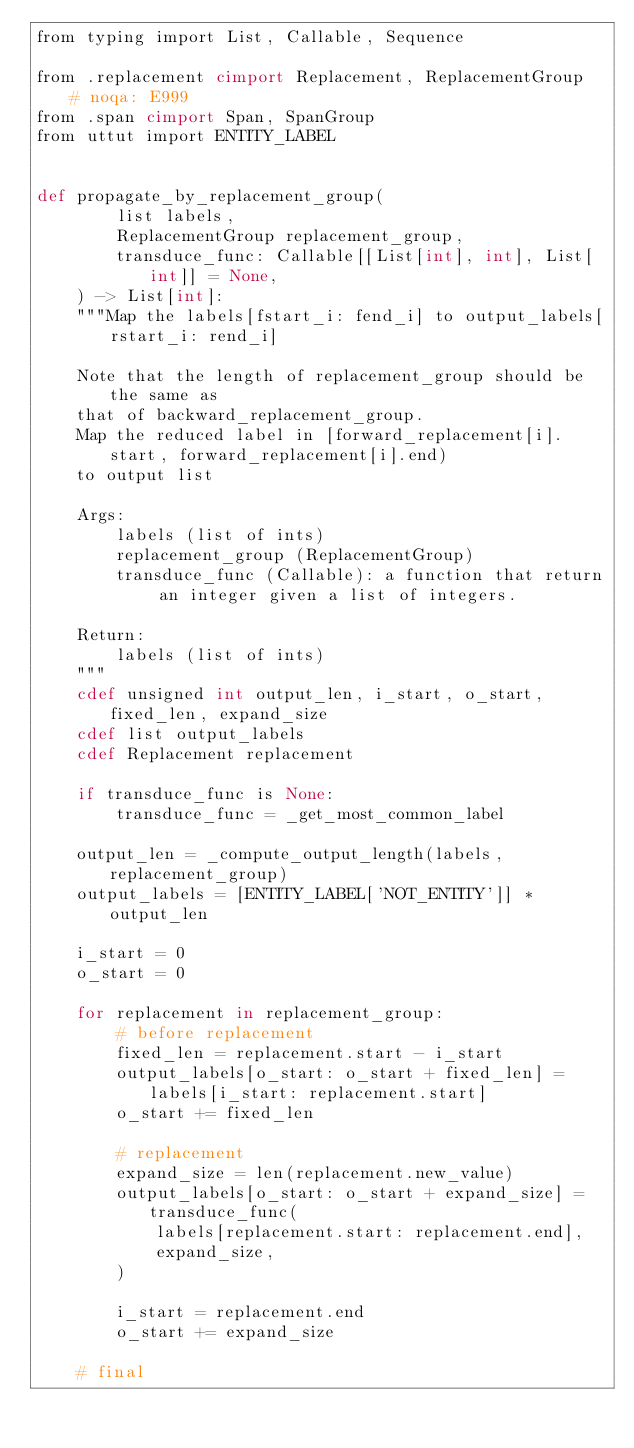<code> <loc_0><loc_0><loc_500><loc_500><_Cython_>from typing import List, Callable, Sequence

from .replacement cimport Replacement, ReplacementGroup  # noqa: E999
from .span cimport Span, SpanGroup
from uttut import ENTITY_LABEL


def propagate_by_replacement_group(
        list labels,
        ReplacementGroup replacement_group,
        transduce_func: Callable[[List[int], int], List[int]] = None,
    ) -> List[int]:
    """Map the labels[fstart_i: fend_i] to output_labels[rstart_i: rend_i]

    Note that the length of replacement_group should be the same as
    that of backward_replacement_group.
    Map the reduced label in [forward_replacement[i].start, forward_replacement[i].end)
    to output list

    Args:
        labels (list of ints)
        replacement_group (ReplacementGroup)
        transduce_func (Callable): a function that return an integer given a list of integers.

    Return:
        labels (list of ints)
    """
    cdef unsigned int output_len, i_start, o_start, fixed_len, expand_size
    cdef list output_labels
    cdef Replacement replacement

    if transduce_func is None:
        transduce_func = _get_most_common_label

    output_len = _compute_output_length(labels, replacement_group)
    output_labels = [ENTITY_LABEL['NOT_ENTITY']] * output_len

    i_start = 0
    o_start = 0

    for replacement in replacement_group:
        # before replacement
        fixed_len = replacement.start - i_start
        output_labels[o_start: o_start + fixed_len] = labels[i_start: replacement.start]
        o_start += fixed_len

        # replacement
        expand_size = len(replacement.new_value)
        output_labels[o_start: o_start + expand_size] = transduce_func(
            labels[replacement.start: replacement.end],
            expand_size,
        )

        i_start = replacement.end
        o_start += expand_size

    # final</code> 